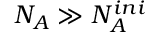Convert formula to latex. <formula><loc_0><loc_0><loc_500><loc_500>N _ { A } \gg N _ { A } ^ { i n i }</formula> 